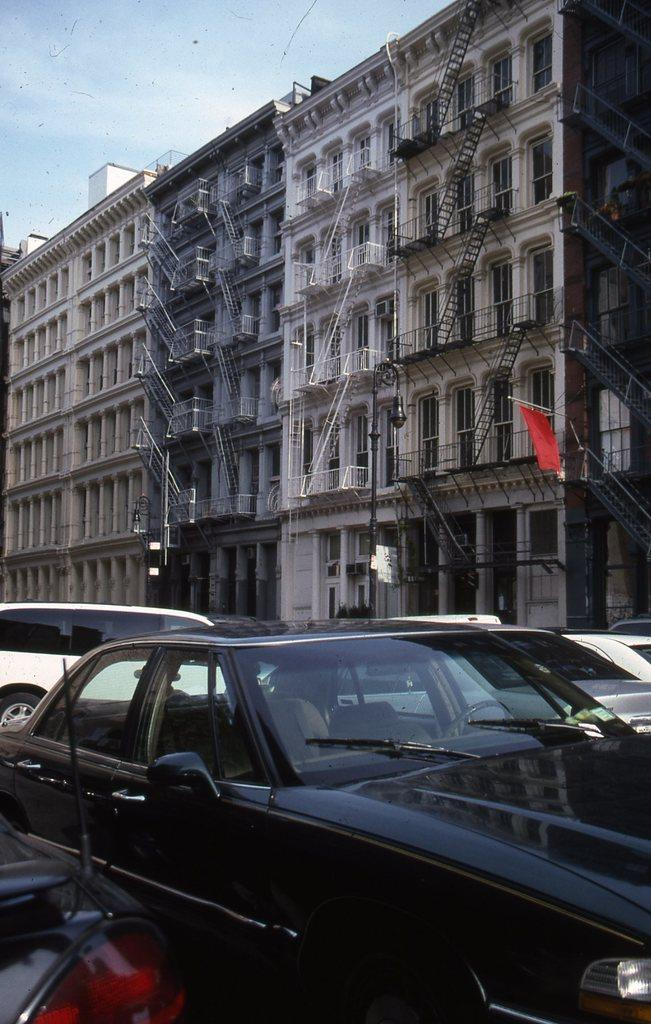What can be seen in the foreground of the image? There are vehicles in the front of the image. What is visible in the background of the image? There are buildings in the background of the image. Can you describe any architectural features in the image? Yes, there are stairs visible in the image, and there is a railing associated with the building. What is visible at the top of the image? The sky is visible at the top of the image. What type of authority is depicted in the image? There is no authority figure present in the image; it features vehicles, buildings, stairs, and a railing. Can you tell me how many hearts are visible in the image? There are no hearts present in the image. 